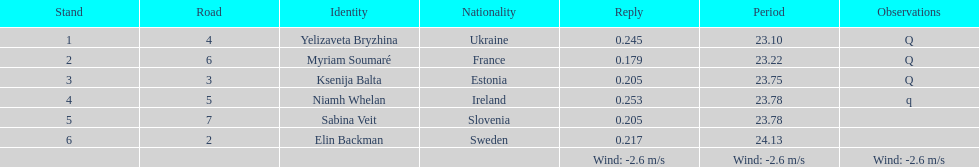Who is the top-ranked player? Yelizaveta Bryzhina. 